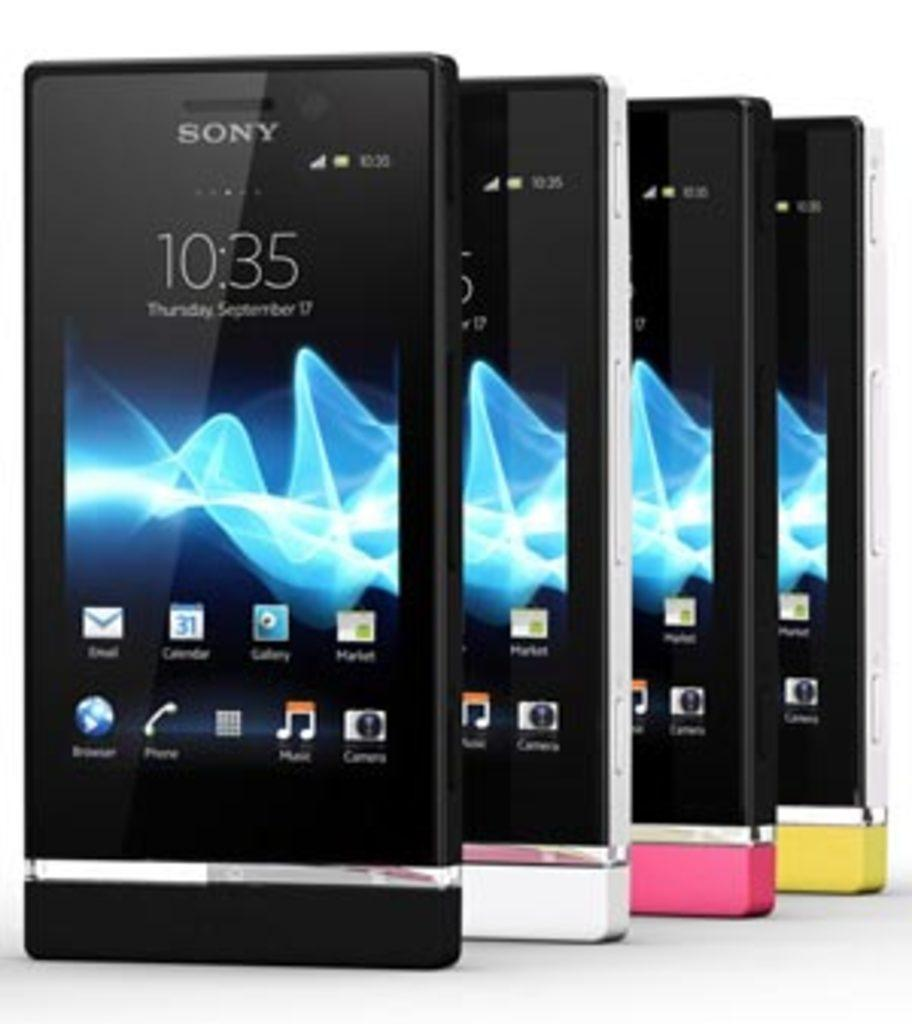<image>
Render a clear and concise summary of the photo. Four Sony cellphones, the bottom colors are black, white, pink and yellow, displaying a time of 10:35 on Thursday, September 17. 